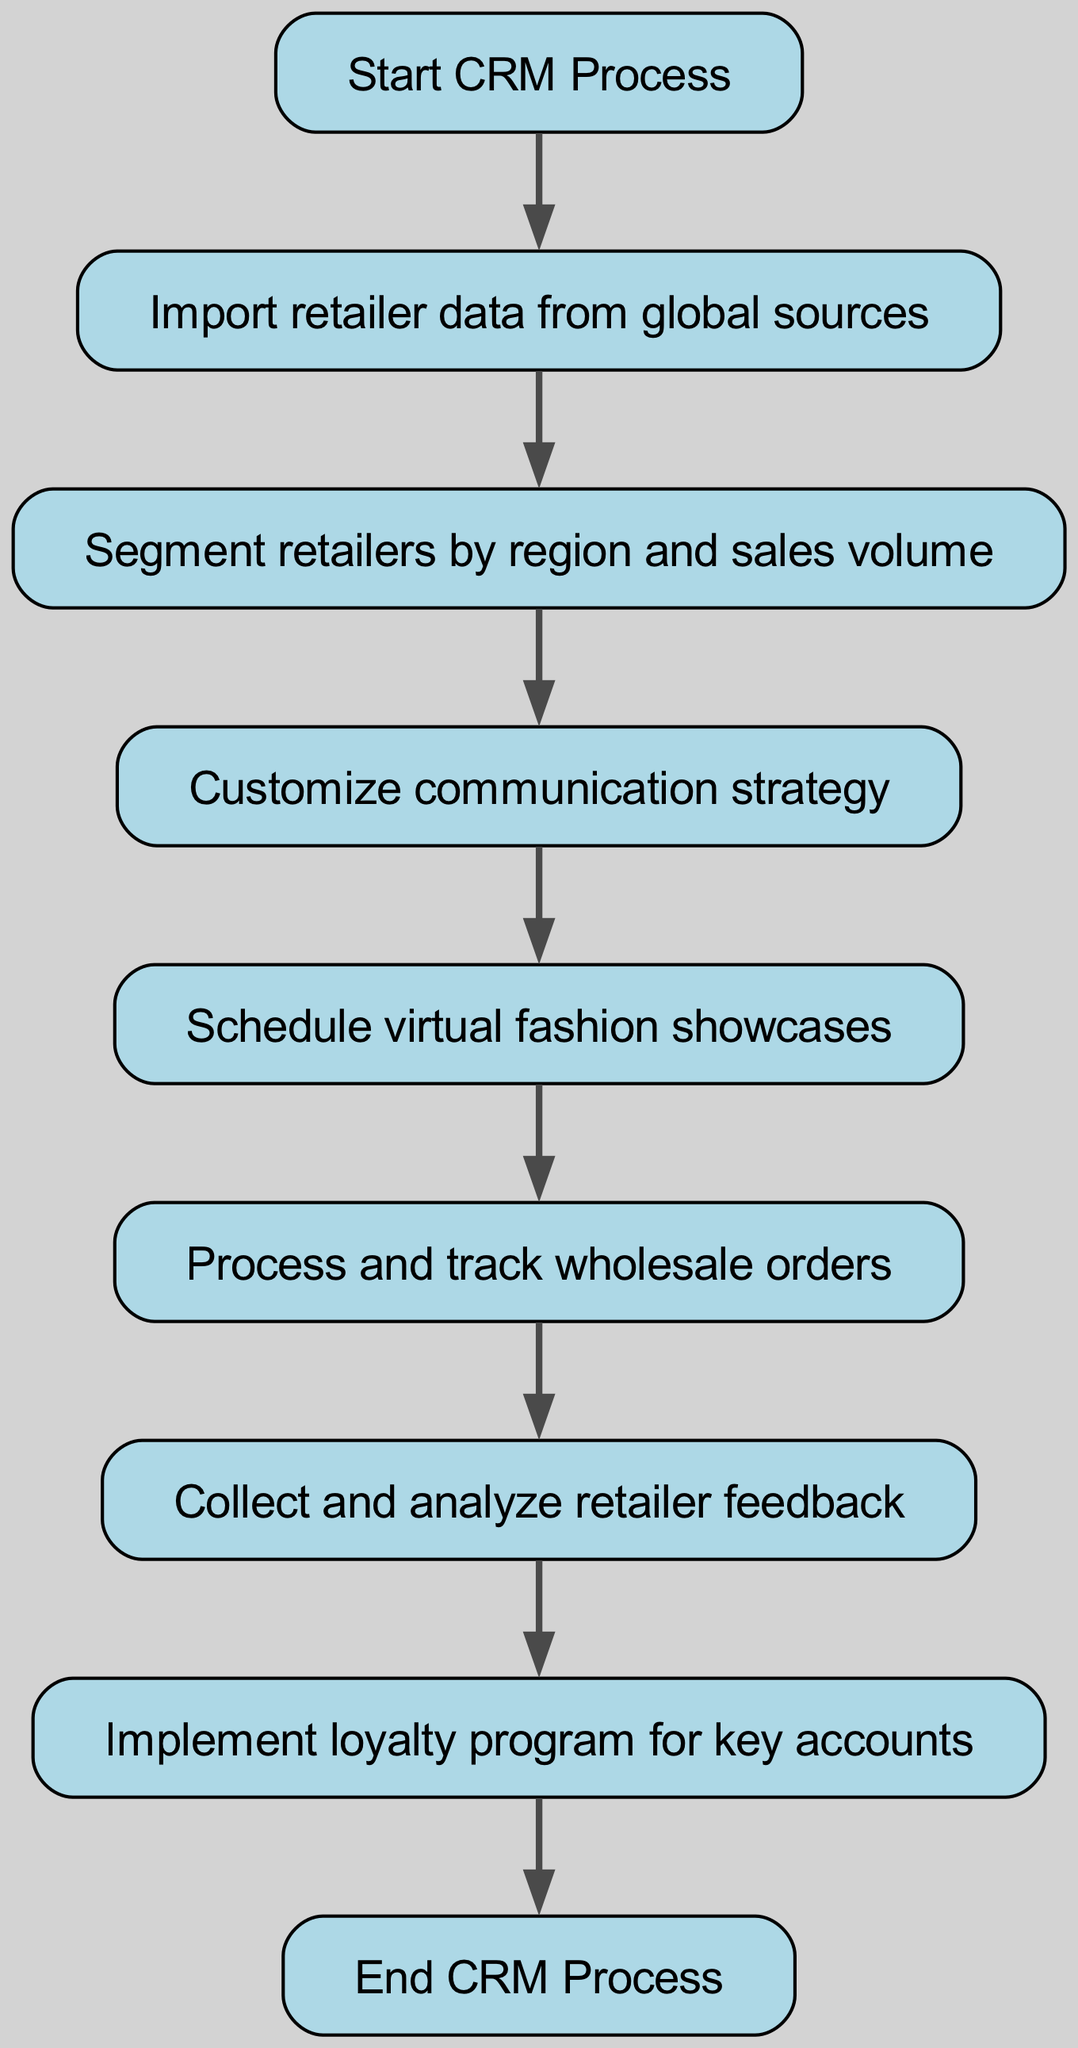What is the first step in the CRM process? The diagram starts with the node labeled "Start CRM Process." This indicates the initiation of the workflow.
Answer: Start CRM Process How many nodes are there in the workflow? By counting the nodes present in the diagram, we find there are a total of 8 nodes listed.
Answer: 8 What node follows the segmentation of retailers? The diagram indicates that after "Segment retailers by region and sales volume," the next step is "Customize communication strategy."
Answer: Customize communication strategy Which node precedes the collection of retailer feedback? Referring to the flow of the diagram, the node immediately leading to "Collect and analyze retailer feedback" is "Process and track wholesale orders."
Answer: Process and track wholesale orders What is the final step in the CRM process workflow? The last node in the sequence of actions in the diagram is labeled "End CRM Process," which signifies the completion of the workflow.
Answer: End CRM Process How many edges are there in the workflow? By examining the connections between the nodes (from 'from' to 'to'), we can determine that there are a total of 8 edges present in the workflow.
Answer: 8 Which step occurs between order processing and retailer feedback? Analyzing the flow from "Process and track wholesale orders," we see that it leads directly to the "Collect and analyze retailer feedback" node.
Answer: Collect and analyze retailer feedback What is the relationship between loyalty and feedback in the workflow? The flow chart shows that after collecting and analyzing retailer feedback, the next step is to implement a loyalty program for key accounts, establishing a direct relationship.
Answer: Implement loyalty program for key accounts 